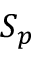<formula> <loc_0><loc_0><loc_500><loc_500>S _ { p }</formula> 